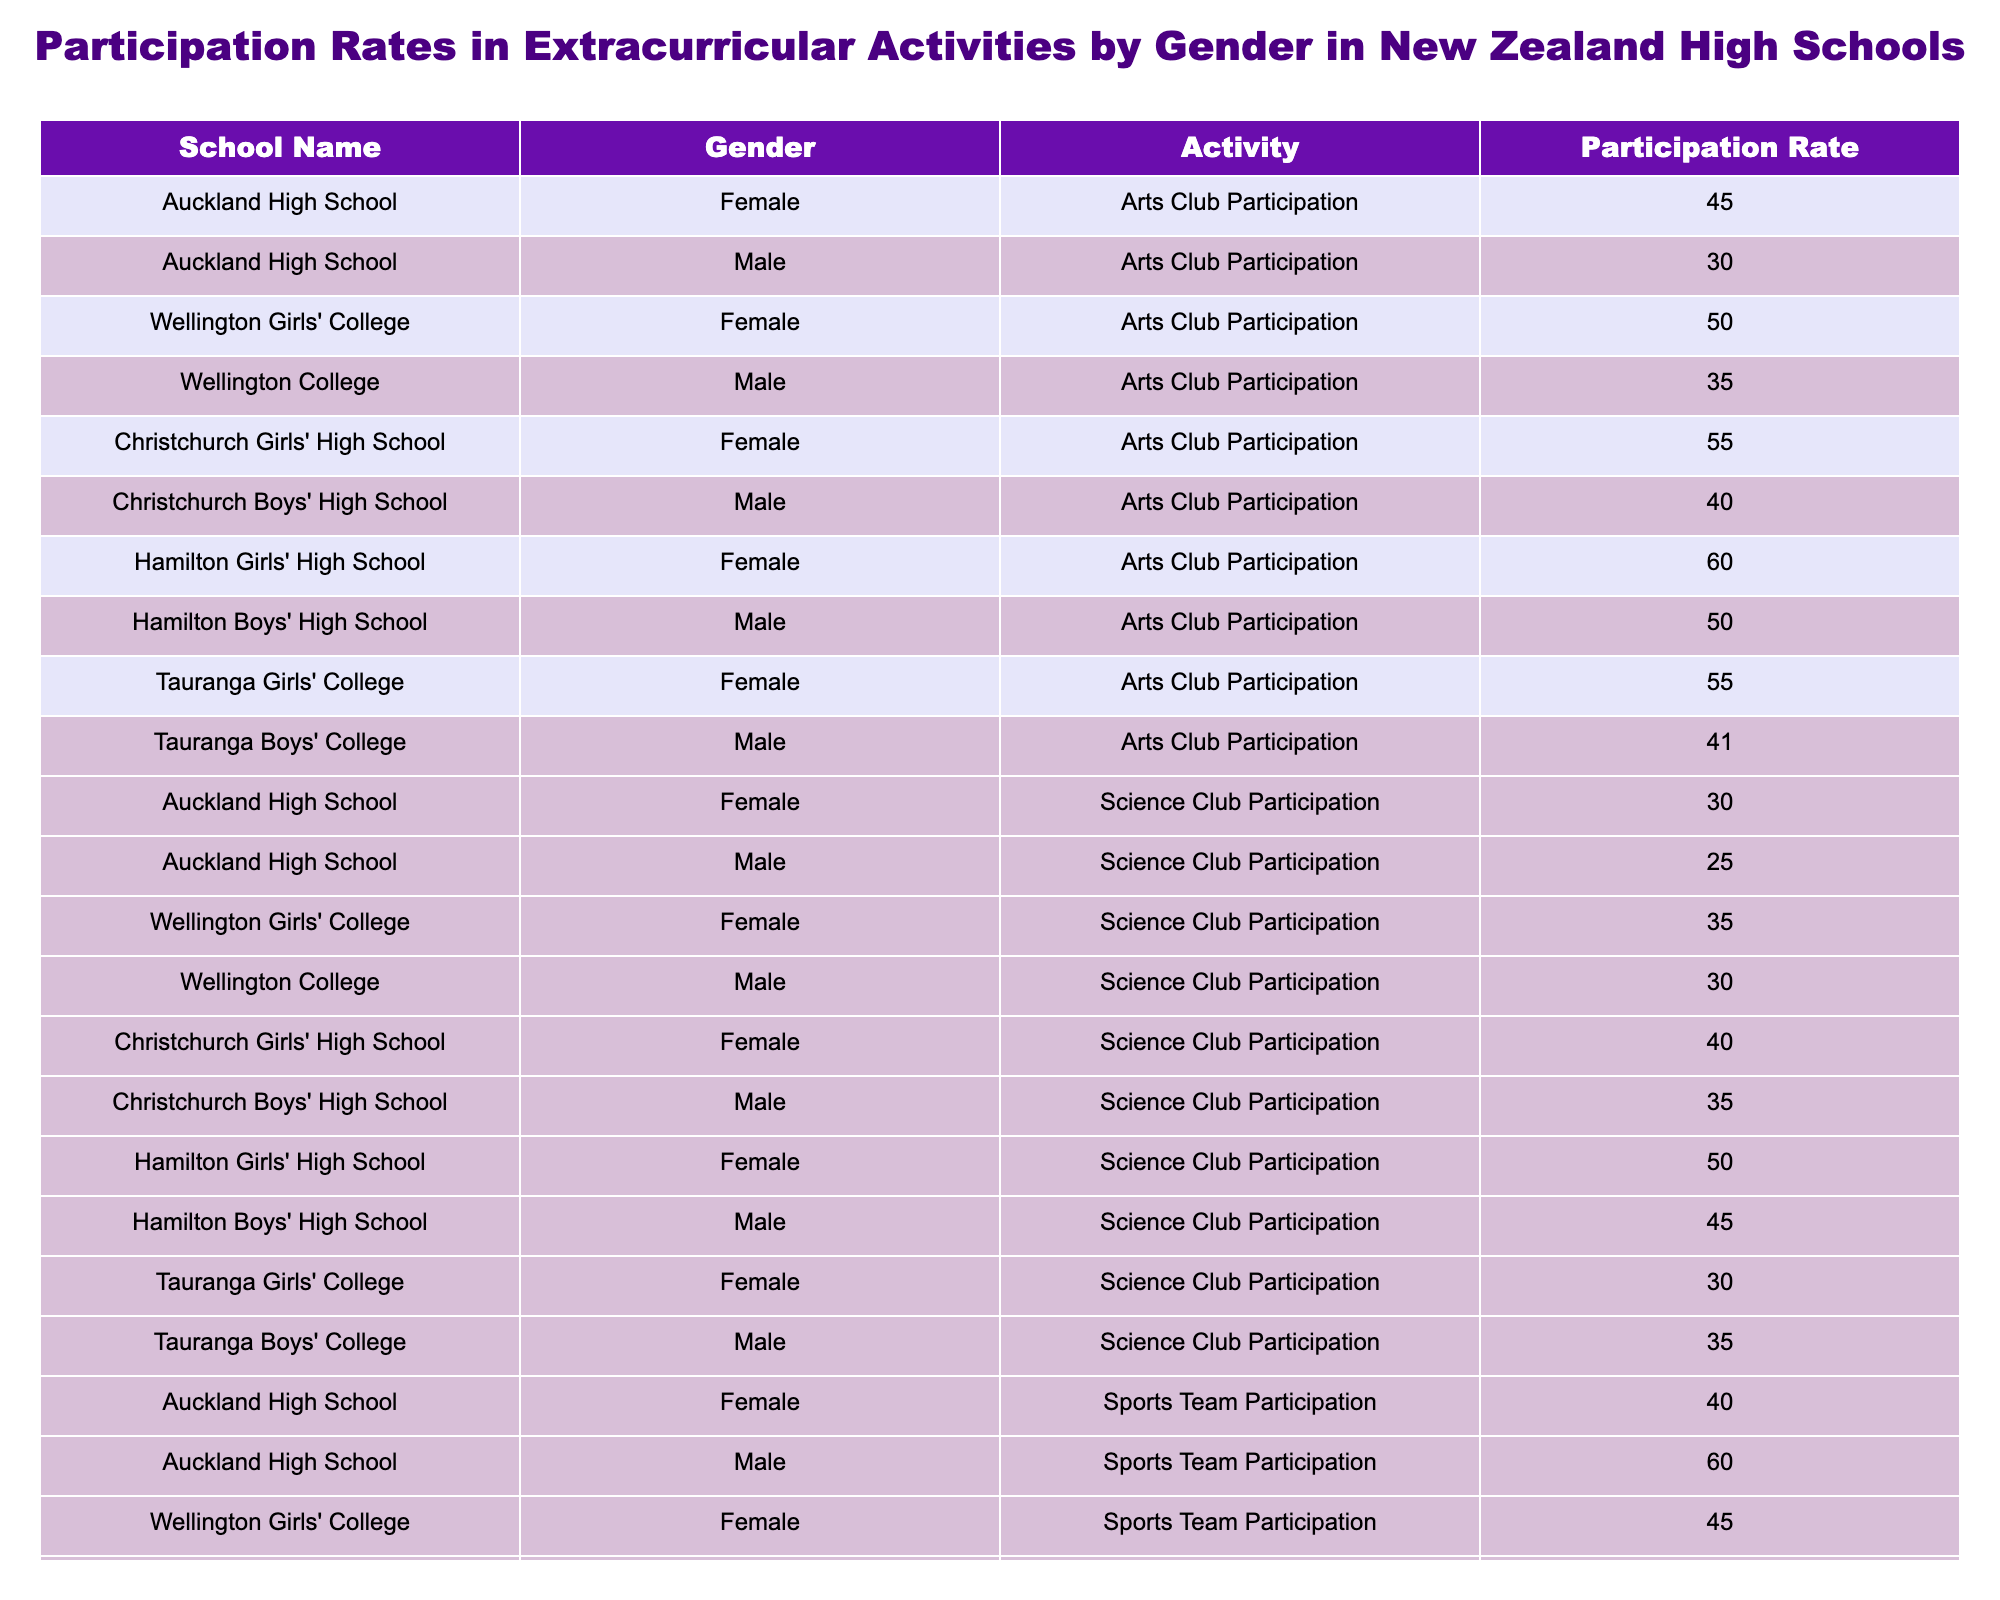What is the participation rate of females in the Arts Club at Auckland High School? The table shows a specific entry for Auckland High School under the Female gender category in the Arts Club Participation column, which indicates a participation rate of 45.
Answer: 45 What is the highest sports team participation rate among male students? By reviewing the Sports Team Participation column for male students, the rates are as follows: 60 (Auckland High School), 65 (Wellington College), 55 (Christchurch Boys' High School), 60 (Hamilton Boys' High School), and 70 (Tauranga Boys' College). The highest among these is 70.
Answer: 70 Is the participation rate of males in the Music Band higher than that of females in the same school? At Christchurch Boys' High School, the male participation rate in the Music Band is 50, while at Christchurch Girls' High School, the female participation rate is 60. Thus, the males do not have a higher participation rate in the Music Band compared to females at the same school.
Answer: No Which school has the highest overall participation rate in all activities for females? To determine the highest overall participation, calculate the sum of the participation rates for females across all activities for each school. The sums are: Auckland High School (220), Wellington Girls' College (245), Christchurch Girls' High School (275), Hamilton Girls' High School (300), and Tauranga Girls' College (275). The highest is Hamilton Girls' High School with 300.
Answer: Hamilton Girls' High School What is the average participation rate for males in the Science Club across all schools? The participation rates for males in the Science Club are: 25 (Auckland High School), 30 (Wellington College), 35 (Christchurch Boys' High School), 45 (Hamilton Boys' High School), and 35 (Tauranga Boys' College). The total is 25 + 30 + 35 + 45 + 35 = 170. There are 5 data points, so the average is 170/5 = 34.
Answer: 34 